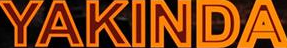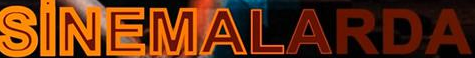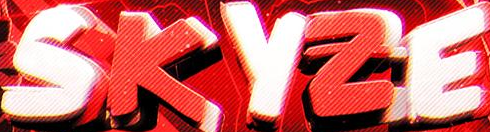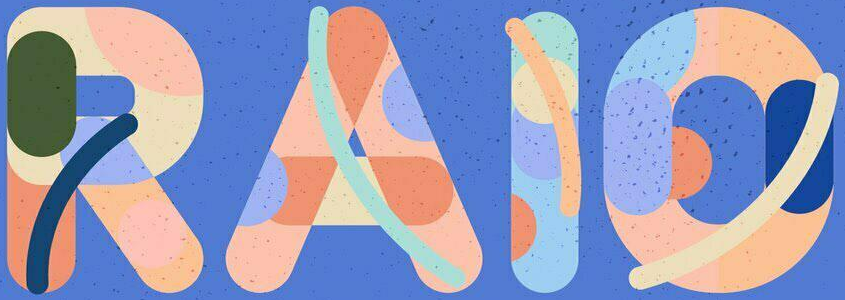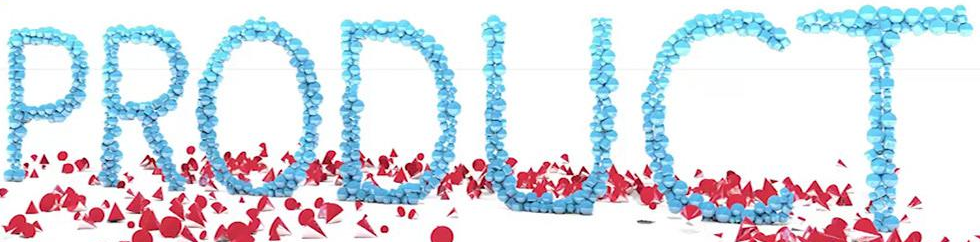What text appears in these images from left to right, separated by a semicolon? YAKINDA; SiNEMALARDA; SKYZE; RAIO; PRODUCT 